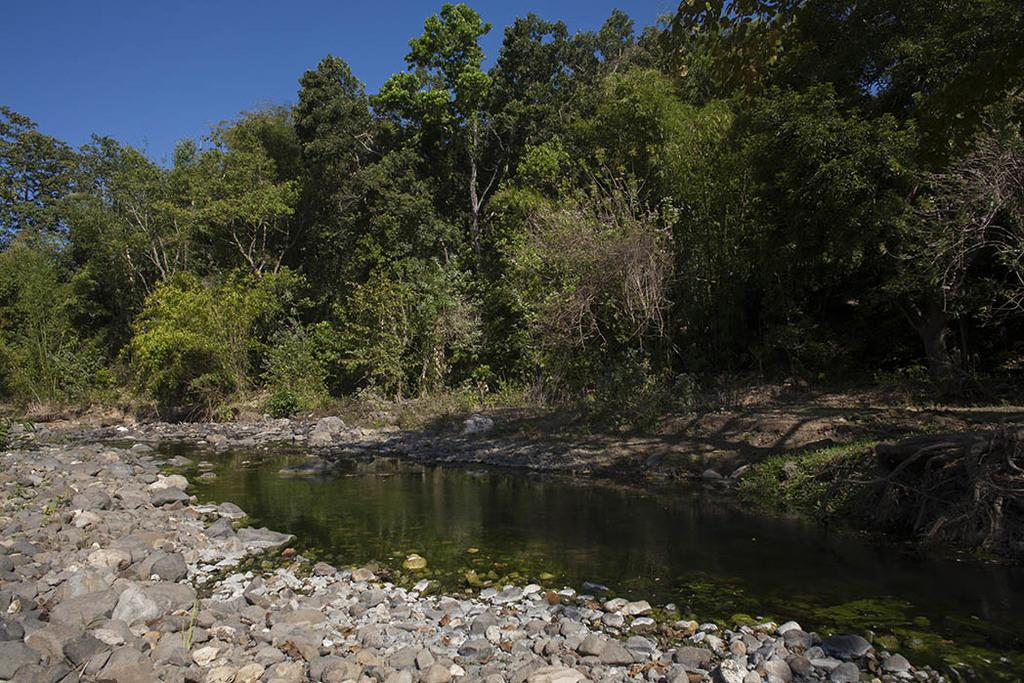What type of vegetation can be seen in the image? There are many trees, plants, and grass visible in the image. What natural element is present in the image besides vegetation? There is water visible in the image. What type of ground surface can be seen in the image? There are stones in the image. What is visible at the top of the image? The sky is visible at the top of the image. What type of rhythm can be heard coming from the channel in the image? There is no channel or rhythm present in the image; it features natural elements such as trees, plants, grass, water, stones, and the sky. How many bears are visible in the image? There are no bears present in the image. 